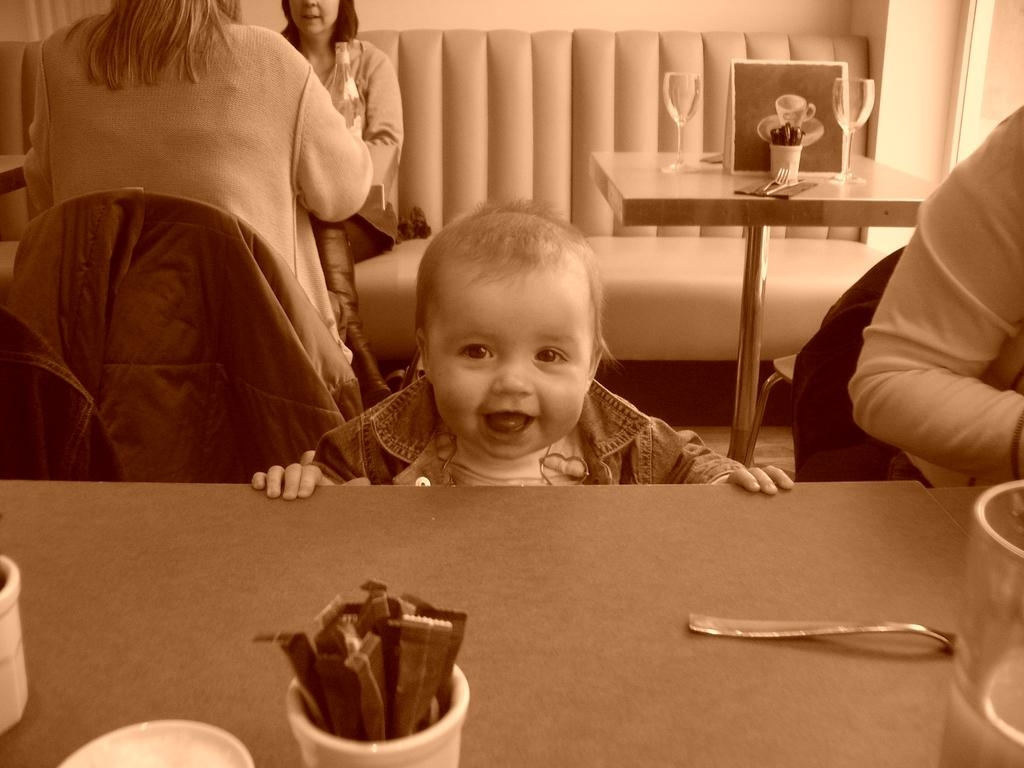What type of furniture can be seen in the image? There are sofas and chairs in the image. What is the primary object in the center of the image? There is a table in the image. What items are placed on the table? There are glasses, a spoon, and a plate on the table. How are the people in the image positioned? The people are sitting on sofas and chairs. Is there a carriage visible in the image? No, there is no carriage present in the image. Can you see a letter on the table? No, there is no letter visible on the table in the image. 